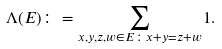<formula> <loc_0><loc_0><loc_500><loc_500>\Lambda ( E ) \colon = \sum _ { x , y , z , w \in E \colon x + y = z + w } 1 .</formula> 